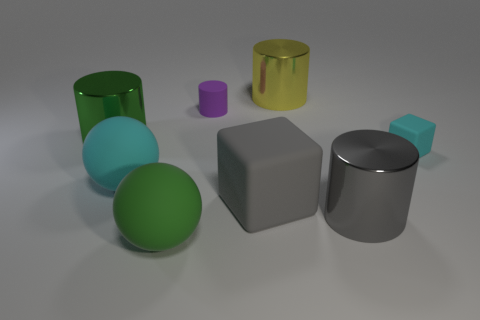What size is the purple matte object that is the same shape as the big green metallic thing?
Offer a terse response. Small. What number of objects are matte objects that are right of the purple rubber cylinder or large metal cylinders that are in front of the tiny cylinder?
Your response must be concise. 4. What shape is the green object that is behind the large ball that is in front of the big cyan rubber sphere?
Your answer should be very brief. Cylinder. Is there anything else that has the same color as the small rubber cylinder?
Your answer should be compact. No. Is there anything else that is the same size as the green cylinder?
Ensure brevity in your answer.  Yes. How many things are green metal things or green matte cylinders?
Your answer should be compact. 1. Is there a yellow sphere that has the same size as the cyan sphere?
Your answer should be very brief. No. What is the shape of the big yellow shiny object?
Make the answer very short. Cylinder. Is the number of tiny purple matte cylinders that are on the right side of the tiny cyan cube greater than the number of gray matte things that are in front of the large gray cylinder?
Make the answer very short. No. There is a large cylinder that is on the left side of the big cyan sphere; does it have the same color as the tiny object on the right side of the rubber cylinder?
Keep it short and to the point. No. 